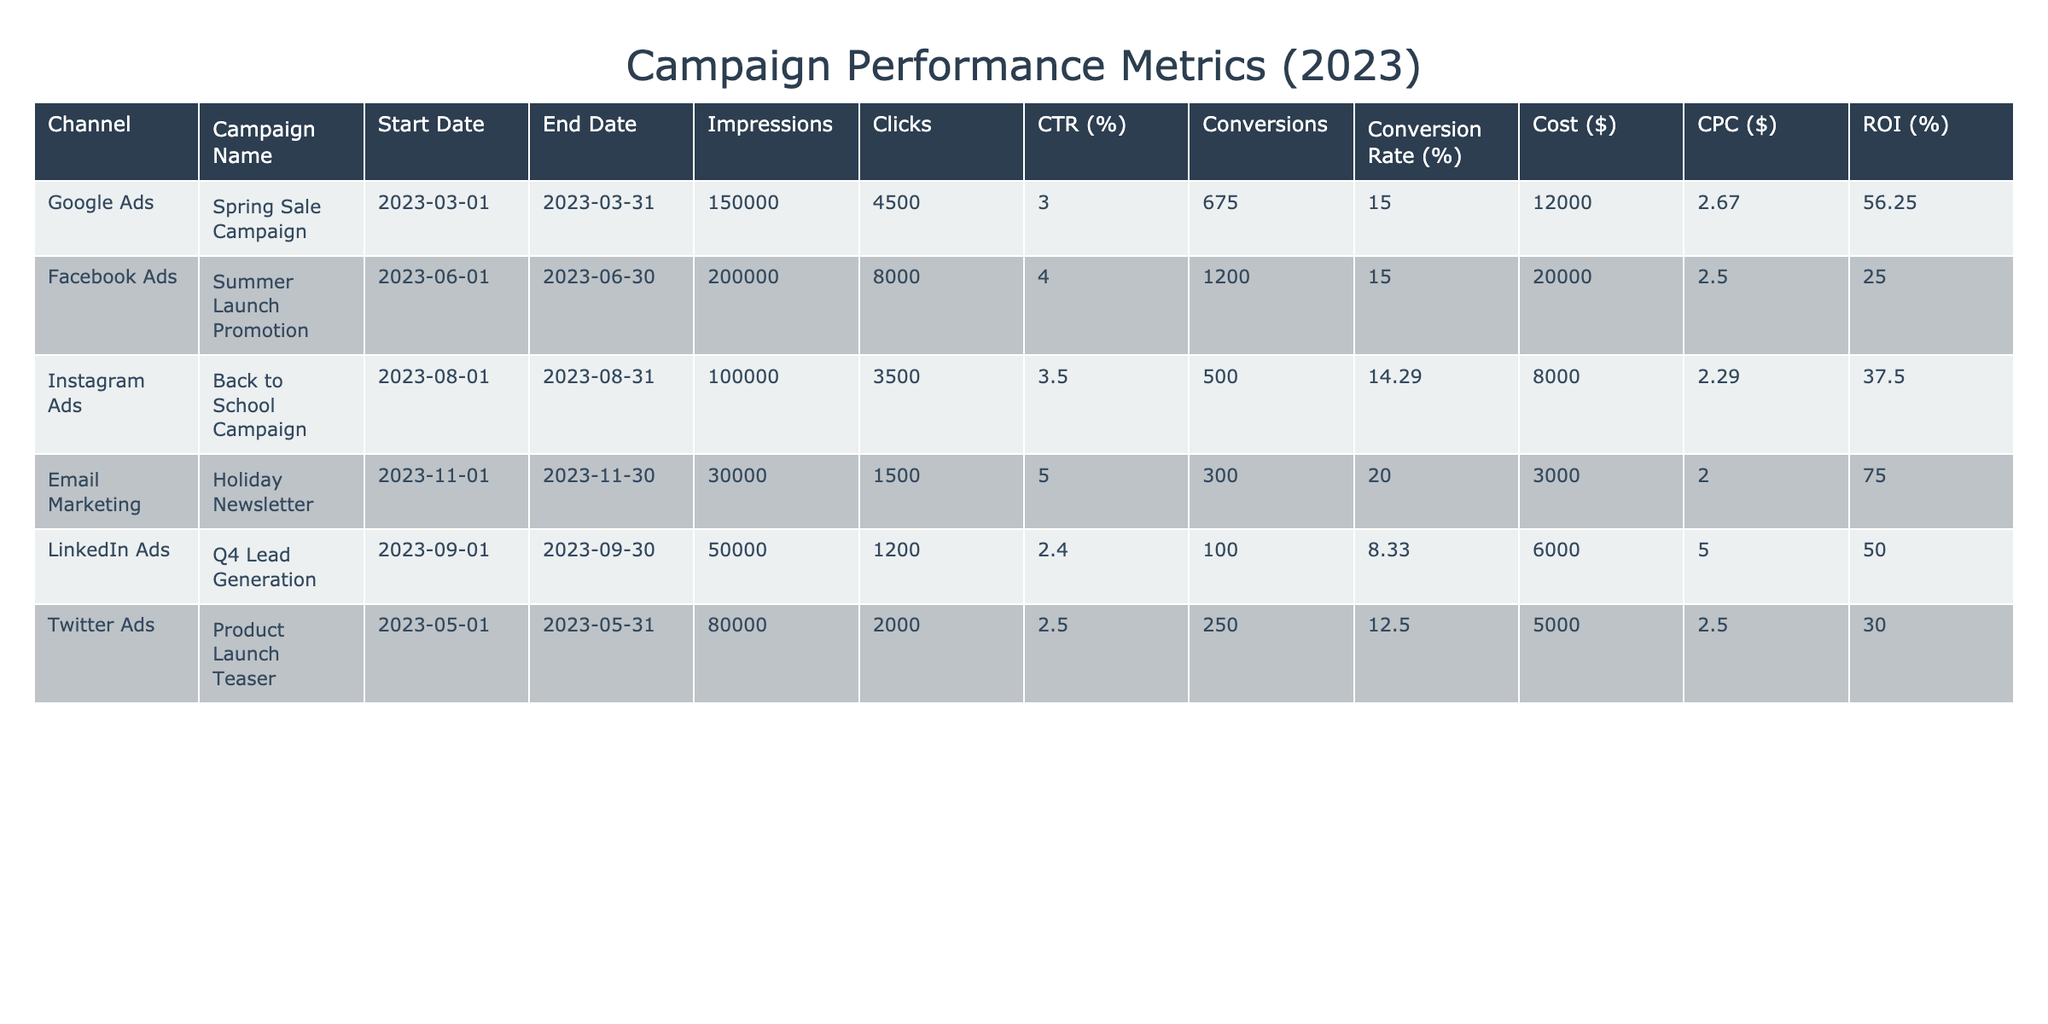What is the total number of impressions for all campaigns listed? To find the total number of impressions, we sum the impressions for each campaign: 150000 (Google Ads) + 200000 (Facebook Ads) + 100000 (Instagram Ads) + 30000 (Email Marketing) + 50000 (LinkedIn Ads) + 80000 (Twitter Ads) = 610000.
Answer: 610000 Which campaign generated the highest click-through rate (CTR)? The click-through rates are: 3.00% (Google Ads), 4.00% (Facebook Ads), 3.50% (Instagram Ads), 5.00% (Email Marketing), 2.40% (LinkedIn Ads), and 2.50% (Twitter Ads). The highest CTR is 5.00% from the Email Marketing campaign.
Answer: Email Marketing What is the total cost of campaigns that achieved a conversion rate higher than 15%? The campaigns with a conversion rate higher than 15% are: Holiday Newsletter (20.00%, $3000) and Spring Sale Campaign (15.00%, $12000). Therefore, the total cost is $3000 + $12000 = $15000.
Answer: 15000 Did the Instagram Ads campaign have a better conversion rate than the LinkedIn Ads? Instagram Ads has a conversion rate of 14.29%, while LinkedIn Ads has a conversion rate of 8.33%. Since 14.29% is greater than 8.33%, the statement is true.
Answer: Yes What is the average cost per click (CPC) across all campaigns? The CPC values are: $2.67 (Google Ads), $2.50 (Facebook Ads), $2.29 (Instagram Ads), $2.00 (Email Marketing), $5.00 (LinkedIn Ads), and $2.50 (Twitter Ads). To find the average, we sum these and then divide by the number of campaigns: (2.67 + 2.50 + 2.29 + 2.00 + 5.00 + 2.50) / 6 = 2.74.
Answer: 2.74 Which campaign had the highest return on investment (ROI)? The ROI percentages are: 56.25% (Google Ads), 25.00% (Facebook Ads), 37.50% (Instagram Ads), 75.00% (Email Marketing), 50.00% (LinkedIn Ads), and 30.00% (Twitter Ads). The highest ROI is 75.00% from the Email Marketing campaign.
Answer: Email Marketing 